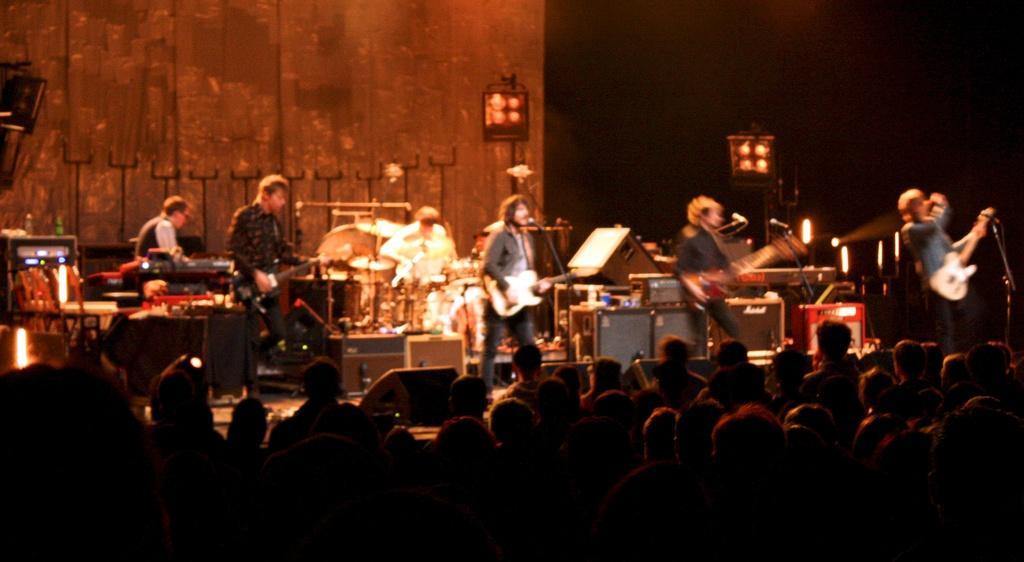Can you describe this image briefly? Bottom of the image few people are standing and watching. In the middle of the image few people are standing and playing guitar and there are some microphones. Behind them there is a wall and there are some drums. 